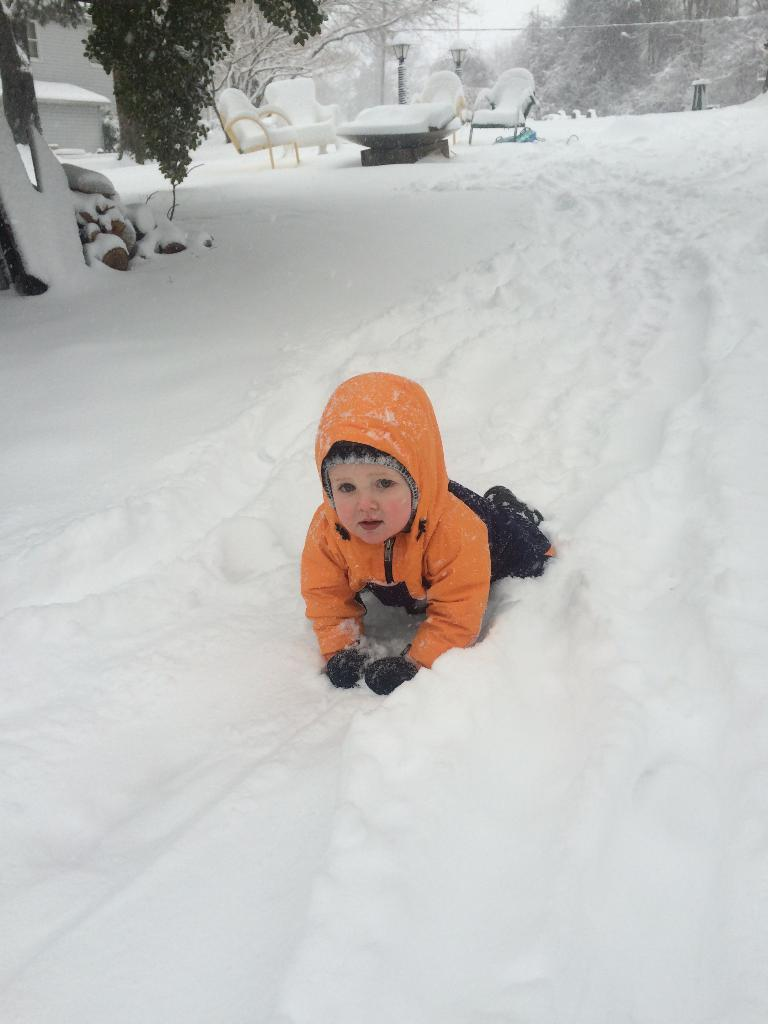Who is present in the image? There is a boy in the image. Where is the boy located? The boy is on a snow land. What can be seen at the top of the image? There are trees, a table covered with snow, and chairs covered with snow visible at the top of the image. What type of bait is the boy using to catch fish in the image? There is no mention of fishing or bait in the image; it features a boy on a snow land. 